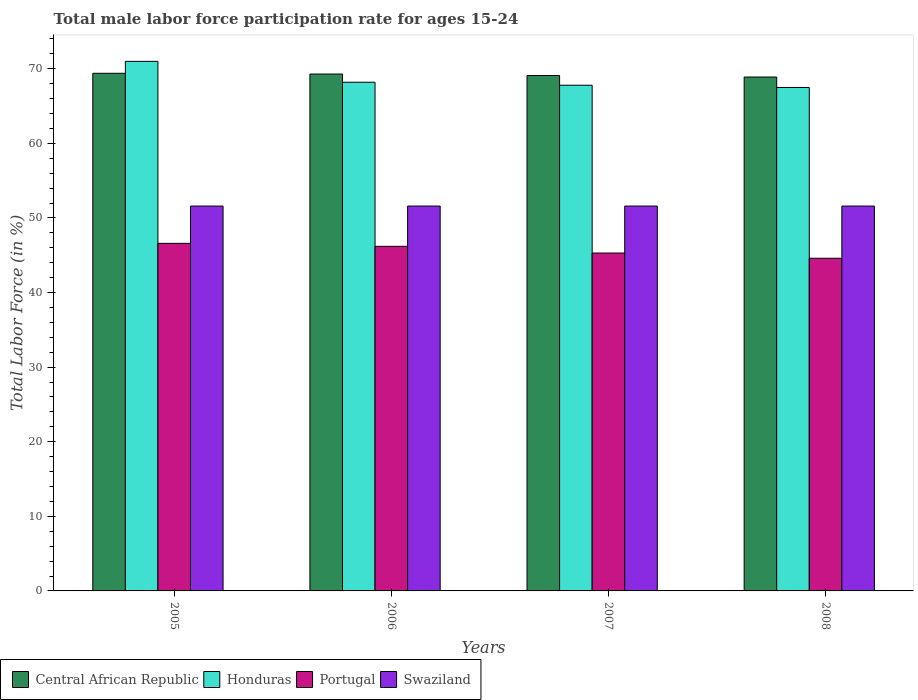How many different coloured bars are there?
Your answer should be compact. 4. How many groups of bars are there?
Your answer should be very brief. 4. Are the number of bars per tick equal to the number of legend labels?
Offer a very short reply. Yes. Are the number of bars on each tick of the X-axis equal?
Offer a very short reply. Yes. How many bars are there on the 1st tick from the right?
Offer a very short reply. 4. What is the male labor force participation rate in Central African Republic in 2005?
Offer a very short reply. 69.4. Across all years, what is the maximum male labor force participation rate in Central African Republic?
Ensure brevity in your answer.  69.4. Across all years, what is the minimum male labor force participation rate in Central African Republic?
Your response must be concise. 68.9. What is the total male labor force participation rate in Central African Republic in the graph?
Offer a very short reply. 276.7. What is the difference between the male labor force participation rate in Honduras in 2005 and that in 2006?
Make the answer very short. 2.8. What is the difference between the male labor force participation rate in Honduras in 2007 and the male labor force participation rate in Portugal in 2005?
Provide a succinct answer. 21.2. What is the average male labor force participation rate in Central African Republic per year?
Offer a terse response. 69.18. In the year 2005, what is the difference between the male labor force participation rate in Swaziland and male labor force participation rate in Honduras?
Provide a short and direct response. -19.4. What is the ratio of the male labor force participation rate in Central African Republic in 2005 to that in 2007?
Offer a terse response. 1. Is the male labor force participation rate in Central African Republic in 2005 less than that in 2008?
Provide a succinct answer. No. What is the difference between the highest and the second highest male labor force participation rate in Central African Republic?
Ensure brevity in your answer.  0.1. In how many years, is the male labor force participation rate in Central African Republic greater than the average male labor force participation rate in Central African Republic taken over all years?
Give a very brief answer. 2. Is the sum of the male labor force participation rate in Swaziland in 2006 and 2008 greater than the maximum male labor force participation rate in Portugal across all years?
Offer a terse response. Yes. Is it the case that in every year, the sum of the male labor force participation rate in Swaziland and male labor force participation rate in Central African Republic is greater than the sum of male labor force participation rate in Honduras and male labor force participation rate in Portugal?
Offer a very short reply. No. What does the 2nd bar from the left in 2005 represents?
Provide a succinct answer. Honduras. What does the 1st bar from the right in 2008 represents?
Offer a terse response. Swaziland. How many bars are there?
Offer a terse response. 16. Are all the bars in the graph horizontal?
Your answer should be very brief. No. How many years are there in the graph?
Your answer should be very brief. 4. Are the values on the major ticks of Y-axis written in scientific E-notation?
Offer a very short reply. No. Where does the legend appear in the graph?
Ensure brevity in your answer.  Bottom left. How many legend labels are there?
Your answer should be very brief. 4. What is the title of the graph?
Keep it short and to the point. Total male labor force participation rate for ages 15-24. What is the label or title of the X-axis?
Offer a terse response. Years. What is the label or title of the Y-axis?
Offer a very short reply. Total Labor Force (in %). What is the Total Labor Force (in %) in Central African Republic in 2005?
Keep it short and to the point. 69.4. What is the Total Labor Force (in %) of Honduras in 2005?
Your answer should be very brief. 71. What is the Total Labor Force (in %) of Portugal in 2005?
Provide a succinct answer. 46.6. What is the Total Labor Force (in %) in Swaziland in 2005?
Provide a succinct answer. 51.6. What is the Total Labor Force (in %) of Central African Republic in 2006?
Make the answer very short. 69.3. What is the Total Labor Force (in %) in Honduras in 2006?
Provide a succinct answer. 68.2. What is the Total Labor Force (in %) of Portugal in 2006?
Offer a terse response. 46.2. What is the Total Labor Force (in %) of Swaziland in 2006?
Keep it short and to the point. 51.6. What is the Total Labor Force (in %) of Central African Republic in 2007?
Give a very brief answer. 69.1. What is the Total Labor Force (in %) in Honduras in 2007?
Your answer should be very brief. 67.8. What is the Total Labor Force (in %) in Portugal in 2007?
Offer a terse response. 45.3. What is the Total Labor Force (in %) of Swaziland in 2007?
Your answer should be very brief. 51.6. What is the Total Labor Force (in %) of Central African Republic in 2008?
Offer a terse response. 68.9. What is the Total Labor Force (in %) in Honduras in 2008?
Your response must be concise. 67.5. What is the Total Labor Force (in %) in Portugal in 2008?
Ensure brevity in your answer.  44.6. What is the Total Labor Force (in %) of Swaziland in 2008?
Keep it short and to the point. 51.6. Across all years, what is the maximum Total Labor Force (in %) in Central African Republic?
Your response must be concise. 69.4. Across all years, what is the maximum Total Labor Force (in %) of Honduras?
Your answer should be compact. 71. Across all years, what is the maximum Total Labor Force (in %) of Portugal?
Your response must be concise. 46.6. Across all years, what is the maximum Total Labor Force (in %) of Swaziland?
Ensure brevity in your answer.  51.6. Across all years, what is the minimum Total Labor Force (in %) of Central African Republic?
Your answer should be very brief. 68.9. Across all years, what is the minimum Total Labor Force (in %) of Honduras?
Offer a terse response. 67.5. Across all years, what is the minimum Total Labor Force (in %) in Portugal?
Keep it short and to the point. 44.6. Across all years, what is the minimum Total Labor Force (in %) in Swaziland?
Offer a very short reply. 51.6. What is the total Total Labor Force (in %) in Central African Republic in the graph?
Make the answer very short. 276.7. What is the total Total Labor Force (in %) of Honduras in the graph?
Provide a succinct answer. 274.5. What is the total Total Labor Force (in %) of Portugal in the graph?
Your answer should be compact. 182.7. What is the total Total Labor Force (in %) of Swaziland in the graph?
Offer a terse response. 206.4. What is the difference between the Total Labor Force (in %) of Honduras in 2005 and that in 2006?
Offer a very short reply. 2.8. What is the difference between the Total Labor Force (in %) of Portugal in 2005 and that in 2006?
Your answer should be very brief. 0.4. What is the difference between the Total Labor Force (in %) in Swaziland in 2005 and that in 2006?
Offer a very short reply. 0. What is the difference between the Total Labor Force (in %) in Honduras in 2005 and that in 2007?
Give a very brief answer. 3.2. What is the difference between the Total Labor Force (in %) of Portugal in 2005 and that in 2007?
Keep it short and to the point. 1.3. What is the difference between the Total Labor Force (in %) of Swaziland in 2005 and that in 2007?
Your answer should be compact. 0. What is the difference between the Total Labor Force (in %) in Honduras in 2005 and that in 2008?
Offer a terse response. 3.5. What is the difference between the Total Labor Force (in %) in Swaziland in 2005 and that in 2008?
Give a very brief answer. 0. What is the difference between the Total Labor Force (in %) of Honduras in 2006 and that in 2007?
Your response must be concise. 0.4. What is the difference between the Total Labor Force (in %) in Portugal in 2006 and that in 2007?
Offer a very short reply. 0.9. What is the difference between the Total Labor Force (in %) of Central African Republic in 2006 and that in 2008?
Ensure brevity in your answer.  0.4. What is the difference between the Total Labor Force (in %) of Portugal in 2006 and that in 2008?
Ensure brevity in your answer.  1.6. What is the difference between the Total Labor Force (in %) in Honduras in 2007 and that in 2008?
Offer a terse response. 0.3. What is the difference between the Total Labor Force (in %) in Portugal in 2007 and that in 2008?
Give a very brief answer. 0.7. What is the difference between the Total Labor Force (in %) of Swaziland in 2007 and that in 2008?
Keep it short and to the point. 0. What is the difference between the Total Labor Force (in %) in Central African Republic in 2005 and the Total Labor Force (in %) in Honduras in 2006?
Give a very brief answer. 1.2. What is the difference between the Total Labor Force (in %) in Central African Republic in 2005 and the Total Labor Force (in %) in Portugal in 2006?
Provide a short and direct response. 23.2. What is the difference between the Total Labor Force (in %) in Honduras in 2005 and the Total Labor Force (in %) in Portugal in 2006?
Provide a succinct answer. 24.8. What is the difference between the Total Labor Force (in %) of Portugal in 2005 and the Total Labor Force (in %) of Swaziland in 2006?
Give a very brief answer. -5. What is the difference between the Total Labor Force (in %) in Central African Republic in 2005 and the Total Labor Force (in %) in Honduras in 2007?
Your answer should be very brief. 1.6. What is the difference between the Total Labor Force (in %) of Central African Republic in 2005 and the Total Labor Force (in %) of Portugal in 2007?
Make the answer very short. 24.1. What is the difference between the Total Labor Force (in %) in Honduras in 2005 and the Total Labor Force (in %) in Portugal in 2007?
Ensure brevity in your answer.  25.7. What is the difference between the Total Labor Force (in %) in Portugal in 2005 and the Total Labor Force (in %) in Swaziland in 2007?
Provide a succinct answer. -5. What is the difference between the Total Labor Force (in %) of Central African Republic in 2005 and the Total Labor Force (in %) of Portugal in 2008?
Give a very brief answer. 24.8. What is the difference between the Total Labor Force (in %) of Central African Republic in 2005 and the Total Labor Force (in %) of Swaziland in 2008?
Your response must be concise. 17.8. What is the difference between the Total Labor Force (in %) of Honduras in 2005 and the Total Labor Force (in %) of Portugal in 2008?
Keep it short and to the point. 26.4. What is the difference between the Total Labor Force (in %) of Honduras in 2005 and the Total Labor Force (in %) of Swaziland in 2008?
Your answer should be compact. 19.4. What is the difference between the Total Labor Force (in %) in Portugal in 2005 and the Total Labor Force (in %) in Swaziland in 2008?
Give a very brief answer. -5. What is the difference between the Total Labor Force (in %) of Central African Republic in 2006 and the Total Labor Force (in %) of Honduras in 2007?
Make the answer very short. 1.5. What is the difference between the Total Labor Force (in %) in Central African Republic in 2006 and the Total Labor Force (in %) in Portugal in 2007?
Make the answer very short. 24. What is the difference between the Total Labor Force (in %) in Honduras in 2006 and the Total Labor Force (in %) in Portugal in 2007?
Keep it short and to the point. 22.9. What is the difference between the Total Labor Force (in %) in Central African Republic in 2006 and the Total Labor Force (in %) in Honduras in 2008?
Your answer should be very brief. 1.8. What is the difference between the Total Labor Force (in %) in Central African Republic in 2006 and the Total Labor Force (in %) in Portugal in 2008?
Offer a very short reply. 24.7. What is the difference between the Total Labor Force (in %) in Central African Republic in 2006 and the Total Labor Force (in %) in Swaziland in 2008?
Give a very brief answer. 17.7. What is the difference between the Total Labor Force (in %) in Honduras in 2006 and the Total Labor Force (in %) in Portugal in 2008?
Your answer should be compact. 23.6. What is the difference between the Total Labor Force (in %) in Honduras in 2006 and the Total Labor Force (in %) in Swaziland in 2008?
Give a very brief answer. 16.6. What is the difference between the Total Labor Force (in %) in Central African Republic in 2007 and the Total Labor Force (in %) in Portugal in 2008?
Keep it short and to the point. 24.5. What is the difference between the Total Labor Force (in %) in Honduras in 2007 and the Total Labor Force (in %) in Portugal in 2008?
Your response must be concise. 23.2. What is the difference between the Total Labor Force (in %) in Honduras in 2007 and the Total Labor Force (in %) in Swaziland in 2008?
Offer a very short reply. 16.2. What is the difference between the Total Labor Force (in %) in Portugal in 2007 and the Total Labor Force (in %) in Swaziland in 2008?
Make the answer very short. -6.3. What is the average Total Labor Force (in %) in Central African Republic per year?
Your answer should be very brief. 69.17. What is the average Total Labor Force (in %) of Honduras per year?
Offer a terse response. 68.62. What is the average Total Labor Force (in %) of Portugal per year?
Your answer should be compact. 45.67. What is the average Total Labor Force (in %) of Swaziland per year?
Your response must be concise. 51.6. In the year 2005, what is the difference between the Total Labor Force (in %) of Central African Republic and Total Labor Force (in %) of Portugal?
Offer a very short reply. 22.8. In the year 2005, what is the difference between the Total Labor Force (in %) in Honduras and Total Labor Force (in %) in Portugal?
Keep it short and to the point. 24.4. In the year 2005, what is the difference between the Total Labor Force (in %) in Honduras and Total Labor Force (in %) in Swaziland?
Your answer should be compact. 19.4. In the year 2005, what is the difference between the Total Labor Force (in %) in Portugal and Total Labor Force (in %) in Swaziland?
Make the answer very short. -5. In the year 2006, what is the difference between the Total Labor Force (in %) in Central African Republic and Total Labor Force (in %) in Portugal?
Offer a terse response. 23.1. In the year 2006, what is the difference between the Total Labor Force (in %) of Honduras and Total Labor Force (in %) of Portugal?
Keep it short and to the point. 22. In the year 2007, what is the difference between the Total Labor Force (in %) of Central African Republic and Total Labor Force (in %) of Honduras?
Keep it short and to the point. 1.3. In the year 2007, what is the difference between the Total Labor Force (in %) of Central African Republic and Total Labor Force (in %) of Portugal?
Make the answer very short. 23.8. In the year 2007, what is the difference between the Total Labor Force (in %) in Central African Republic and Total Labor Force (in %) in Swaziland?
Provide a succinct answer. 17.5. In the year 2007, what is the difference between the Total Labor Force (in %) in Honduras and Total Labor Force (in %) in Swaziland?
Offer a terse response. 16.2. In the year 2007, what is the difference between the Total Labor Force (in %) of Portugal and Total Labor Force (in %) of Swaziland?
Your answer should be very brief. -6.3. In the year 2008, what is the difference between the Total Labor Force (in %) in Central African Republic and Total Labor Force (in %) in Portugal?
Keep it short and to the point. 24.3. In the year 2008, what is the difference between the Total Labor Force (in %) in Honduras and Total Labor Force (in %) in Portugal?
Provide a succinct answer. 22.9. In the year 2008, what is the difference between the Total Labor Force (in %) of Portugal and Total Labor Force (in %) of Swaziland?
Ensure brevity in your answer.  -7. What is the ratio of the Total Labor Force (in %) in Central African Republic in 2005 to that in 2006?
Provide a succinct answer. 1. What is the ratio of the Total Labor Force (in %) in Honduras in 2005 to that in 2006?
Provide a succinct answer. 1.04. What is the ratio of the Total Labor Force (in %) in Portugal in 2005 to that in 2006?
Give a very brief answer. 1.01. What is the ratio of the Total Labor Force (in %) of Swaziland in 2005 to that in 2006?
Offer a terse response. 1. What is the ratio of the Total Labor Force (in %) of Honduras in 2005 to that in 2007?
Provide a short and direct response. 1.05. What is the ratio of the Total Labor Force (in %) of Portugal in 2005 to that in 2007?
Offer a very short reply. 1.03. What is the ratio of the Total Labor Force (in %) in Central African Republic in 2005 to that in 2008?
Provide a succinct answer. 1.01. What is the ratio of the Total Labor Force (in %) of Honduras in 2005 to that in 2008?
Provide a succinct answer. 1.05. What is the ratio of the Total Labor Force (in %) of Portugal in 2005 to that in 2008?
Keep it short and to the point. 1.04. What is the ratio of the Total Labor Force (in %) in Swaziland in 2005 to that in 2008?
Your response must be concise. 1. What is the ratio of the Total Labor Force (in %) in Central African Republic in 2006 to that in 2007?
Make the answer very short. 1. What is the ratio of the Total Labor Force (in %) in Honduras in 2006 to that in 2007?
Your answer should be very brief. 1.01. What is the ratio of the Total Labor Force (in %) in Portugal in 2006 to that in 2007?
Offer a very short reply. 1.02. What is the ratio of the Total Labor Force (in %) of Swaziland in 2006 to that in 2007?
Give a very brief answer. 1. What is the ratio of the Total Labor Force (in %) of Honduras in 2006 to that in 2008?
Ensure brevity in your answer.  1.01. What is the ratio of the Total Labor Force (in %) of Portugal in 2006 to that in 2008?
Your answer should be compact. 1.04. What is the ratio of the Total Labor Force (in %) of Portugal in 2007 to that in 2008?
Ensure brevity in your answer.  1.02. What is the difference between the highest and the second highest Total Labor Force (in %) in Central African Republic?
Keep it short and to the point. 0.1. What is the difference between the highest and the second highest Total Labor Force (in %) in Portugal?
Provide a short and direct response. 0.4. What is the difference between the highest and the lowest Total Labor Force (in %) of Central African Republic?
Give a very brief answer. 0.5. What is the difference between the highest and the lowest Total Labor Force (in %) in Swaziland?
Make the answer very short. 0. 